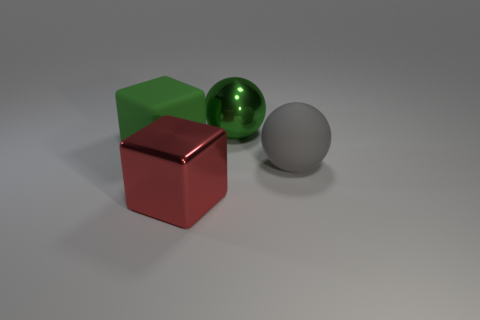Add 3 small yellow rubber spheres. How many objects exist? 7 Subtract 1 cubes. How many cubes are left? 1 Subtract all gray spheres. How many spheres are left? 1 Subtract all large gray matte spheres. Subtract all green things. How many objects are left? 1 Add 1 red shiny blocks. How many red shiny blocks are left? 2 Add 3 large red shiny blocks. How many large red shiny blocks exist? 4 Subtract 1 green cubes. How many objects are left? 3 Subtract all green spheres. Subtract all cyan cylinders. How many spheres are left? 1 